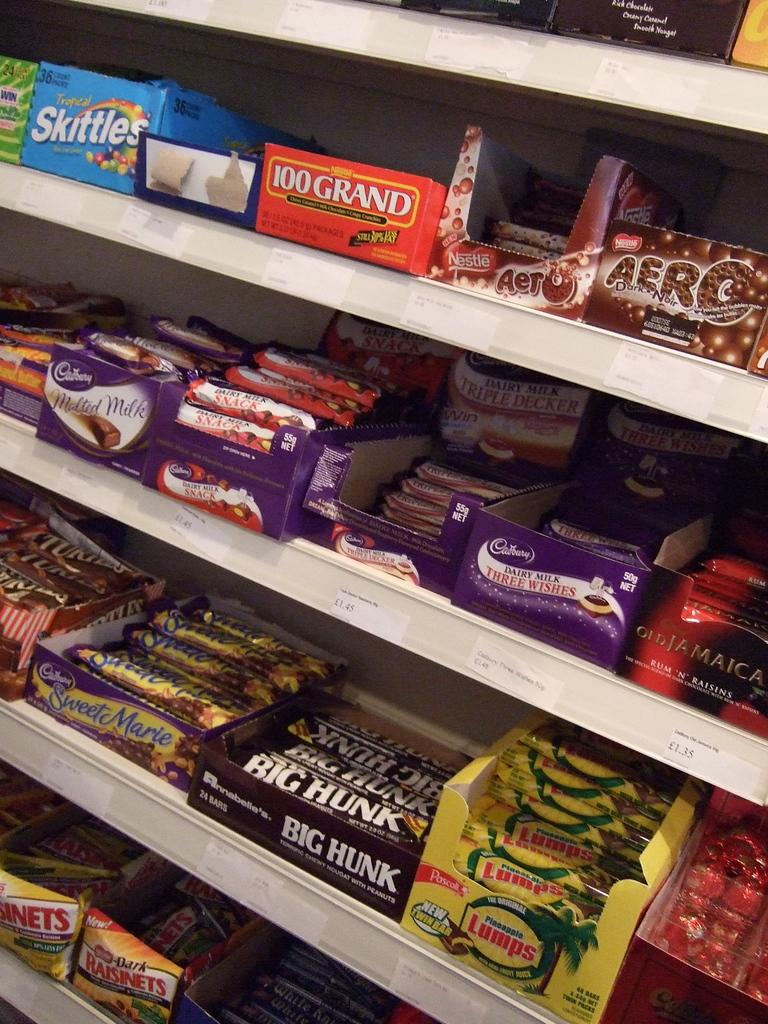<image>
Summarize the visual content of the image. a candy bar display in a store for candies like Big Hunk and Aero 